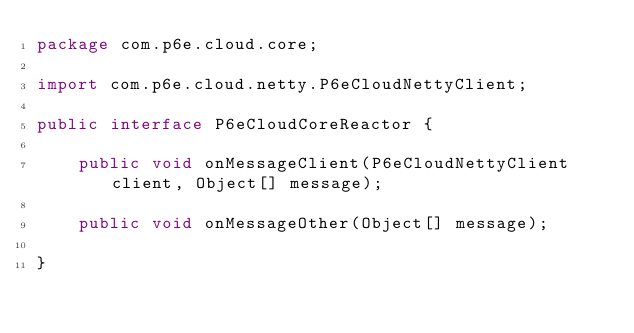Convert code to text. <code><loc_0><loc_0><loc_500><loc_500><_Java_>package com.p6e.cloud.core;

import com.p6e.cloud.netty.P6eCloudNettyClient;

public interface P6eCloudCoreReactor {

    public void onMessageClient(P6eCloudNettyClient client, Object[] message);

    public void onMessageOther(Object[] message);

}
</code> 